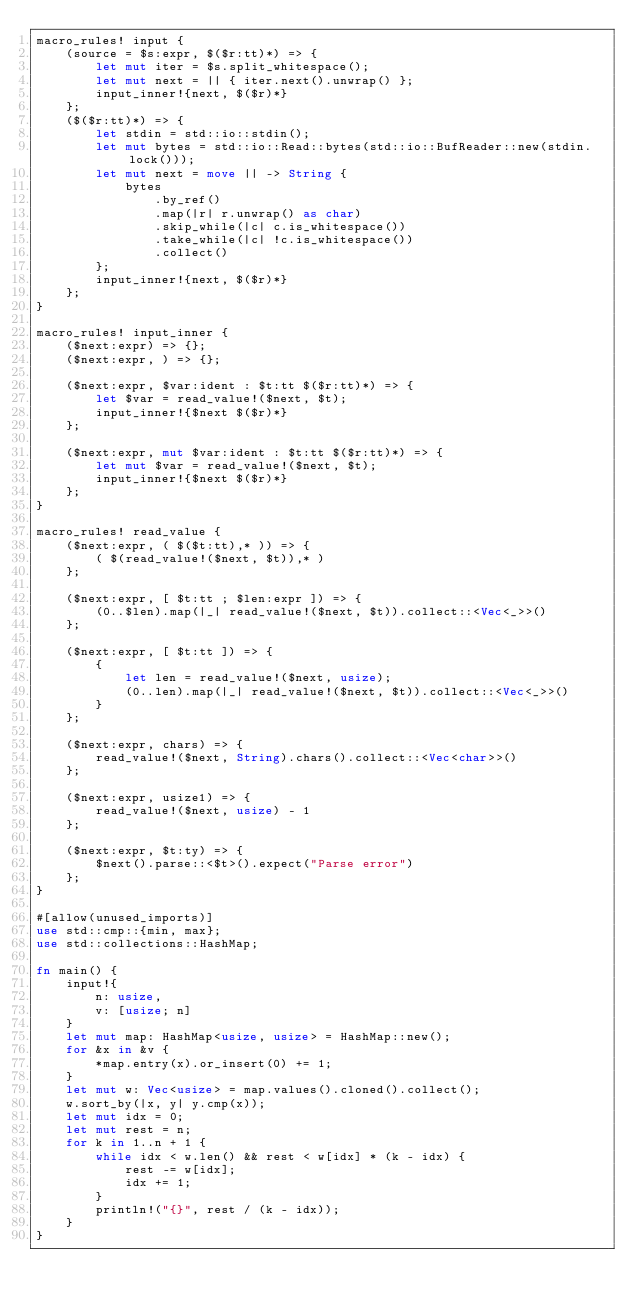<code> <loc_0><loc_0><loc_500><loc_500><_Rust_>macro_rules! input {
    (source = $s:expr, $($r:tt)*) => {
        let mut iter = $s.split_whitespace();
        let mut next = || { iter.next().unwrap() };
        input_inner!{next, $($r)*}
    };
    ($($r:tt)*) => {
        let stdin = std::io::stdin();
        let mut bytes = std::io::Read::bytes(std::io::BufReader::new(stdin.lock()));
        let mut next = move || -> String {
            bytes
                .by_ref()
                .map(|r| r.unwrap() as char)
                .skip_while(|c| c.is_whitespace())
                .take_while(|c| !c.is_whitespace())
                .collect()
        };
        input_inner!{next, $($r)*}
    };
}

macro_rules! input_inner {
    ($next:expr) => {};
    ($next:expr, ) => {};

    ($next:expr, $var:ident : $t:tt $($r:tt)*) => {
        let $var = read_value!($next, $t);
        input_inner!{$next $($r)*}
    };

    ($next:expr, mut $var:ident : $t:tt $($r:tt)*) => {
        let mut $var = read_value!($next, $t);
        input_inner!{$next $($r)*}
    };
}

macro_rules! read_value {
    ($next:expr, ( $($t:tt),* )) => {
        ( $(read_value!($next, $t)),* )
    };

    ($next:expr, [ $t:tt ; $len:expr ]) => {
        (0..$len).map(|_| read_value!($next, $t)).collect::<Vec<_>>()
    };

    ($next:expr, [ $t:tt ]) => {
        {
            let len = read_value!($next, usize);
            (0..len).map(|_| read_value!($next, $t)).collect::<Vec<_>>()
        }
    };

    ($next:expr, chars) => {
        read_value!($next, String).chars().collect::<Vec<char>>()
    };

    ($next:expr, usize1) => {
        read_value!($next, usize) - 1
    };

    ($next:expr, $t:ty) => {
        $next().parse::<$t>().expect("Parse error")
    };
}

#[allow(unused_imports)]
use std::cmp::{min, max};
use std::collections::HashMap;

fn main() {
    input!{
        n: usize,
        v: [usize; n]
    }
    let mut map: HashMap<usize, usize> = HashMap::new();
    for &x in &v {
        *map.entry(x).or_insert(0) += 1;
    }
    let mut w: Vec<usize> = map.values().cloned().collect();
    w.sort_by(|x, y| y.cmp(x));
    let mut idx = 0;
    let mut rest = n;
    for k in 1..n + 1 {
        while idx < w.len() && rest < w[idx] * (k - idx) {
            rest -= w[idx];
            idx += 1;
        }
        println!("{}", rest / (k - idx));
    }
}
</code> 